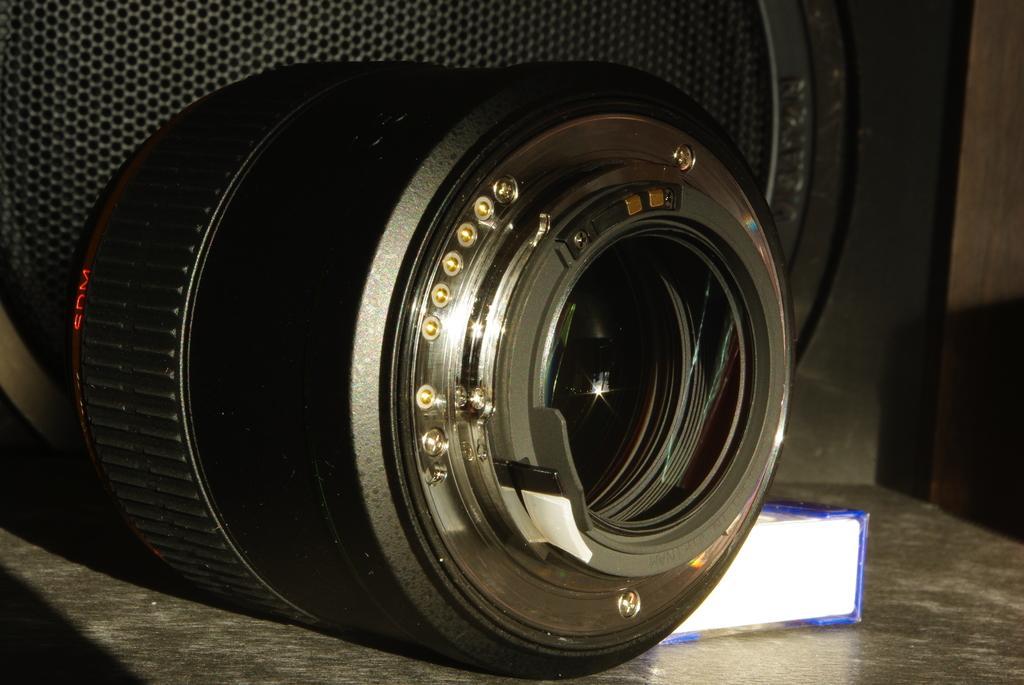Could you give a brief overview of what you see in this image? In the foreground of this image, there is a camera lens on the stone surface. Behind it, there is a box and speaker like an object. 